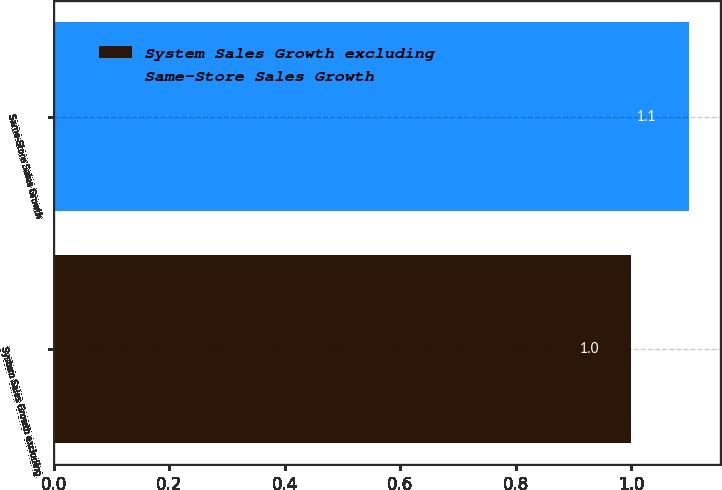Convert chart to OTSL. <chart><loc_0><loc_0><loc_500><loc_500><bar_chart><fcel>System Sales Growth excluding<fcel>Same-Store Sales Growth<nl><fcel>1<fcel>1.1<nl></chart> 